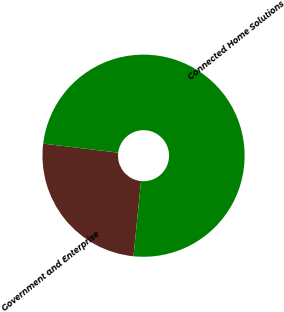Convert chart. <chart><loc_0><loc_0><loc_500><loc_500><pie_chart><fcel>Government and Enterprise<fcel>Connected Home Solutions<nl><fcel>25.32%<fcel>74.68%<nl></chart> 